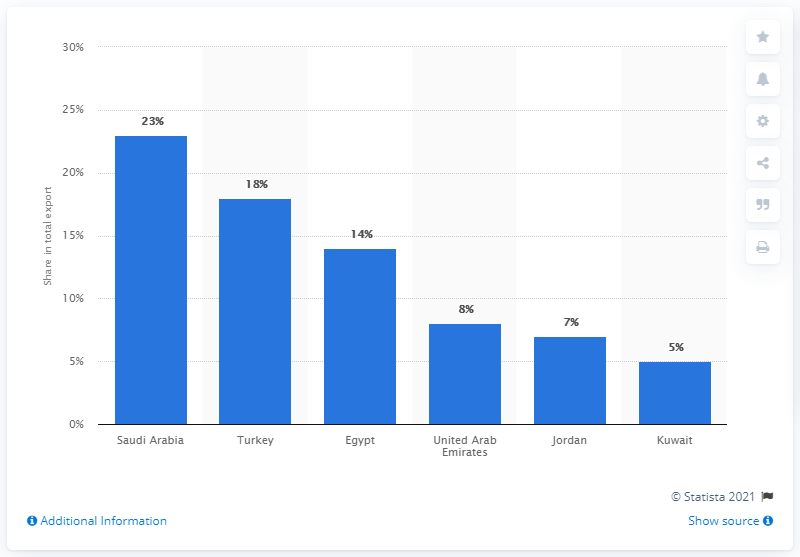List a handful of essential elements in this visual. In 2019, Saudi Arabia was Syria's most significant export partner, accounting for a significant portion of the country's exports. 